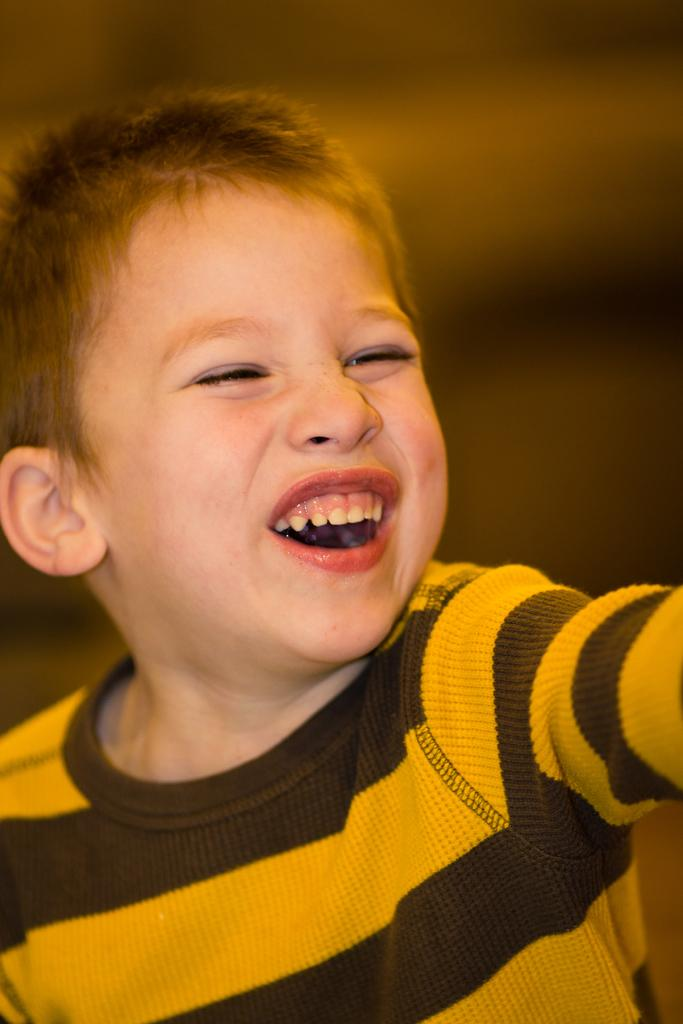What is the main subject of the image? The main subject of the image is a boy. What is the boy wearing? The boy is wearing a yellow and brown color combination T-shirt. What is the boy's facial expression in the image? The boy is smiling. Can you describe the background of the image? The background of the image is blurred. How many trucks can be seen in the image? There are no trucks present in the image. What type of mice are visible in the image? There are no mice present in the image. 